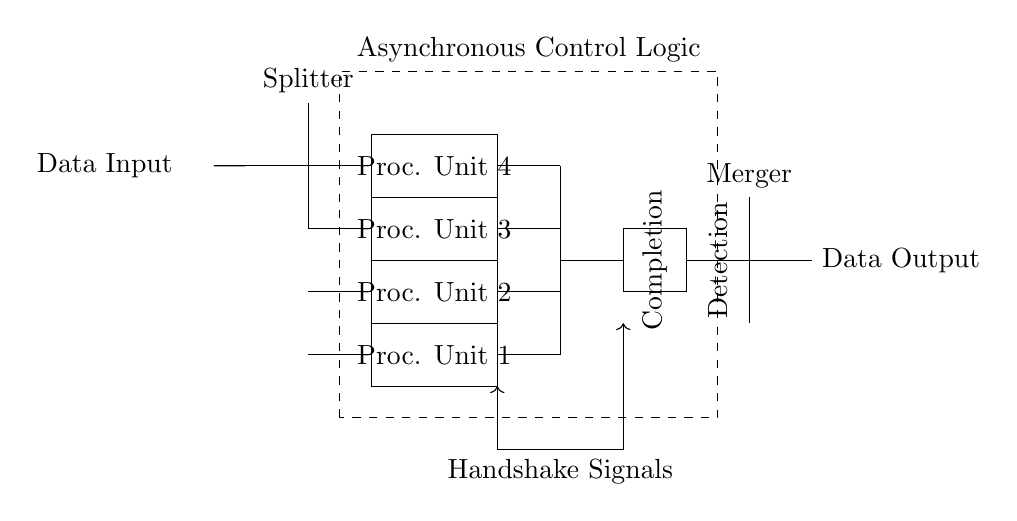What are the components present in the circuit? The components in the circuit include a splitter, four processing units, a completion detection unit, a merger, and asynchronous control logic.
Answer: Splitter, Processing Units, Completion Detection, Merger, Asynchronous Control How many processing units are there? The circuit diagram shows four processing units connected in parallel to process data.
Answer: Four What is the purpose of the handshake signals? The handshake signals are used for coordination between the processing units and the asynchronous control logic, ensuring that data is processed efficiently with proper timing.
Answer: Coordination What detects the completion of processing in the circuit? The completion detection unit is responsible for monitoring the processing units and determining when all processing tasks have been completed.
Answer: Completion Detection Unit What type of logic is illustrated in the circuit? The circuit illustrates asynchronous logic, which allows for non-blocking and independent operation of the processing units.
Answer: Asynchronous Logic How is the output data obtained? The output data is obtained by merging the results from the processing units through the merger component after completion detection.
Answer: Merging Results What is the orientation of the asynchronous control logic in the circuit? The asynchronous control logic is positioned above the main processing units and controls the operation flow of the circuit with handshake signals.
Answer: Above Processing Units 